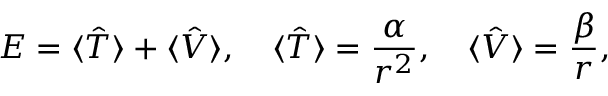Convert formula to latex. <formula><loc_0><loc_0><loc_500><loc_500>E = \langle \hat { T } \rangle + \langle \hat { V } \rangle , \quad \langle \hat { T } \rangle = \frac { \alpha } { r ^ { 2 } } , \quad \langle \hat { V } \rangle = \frac { \beta } { r } ,</formula> 